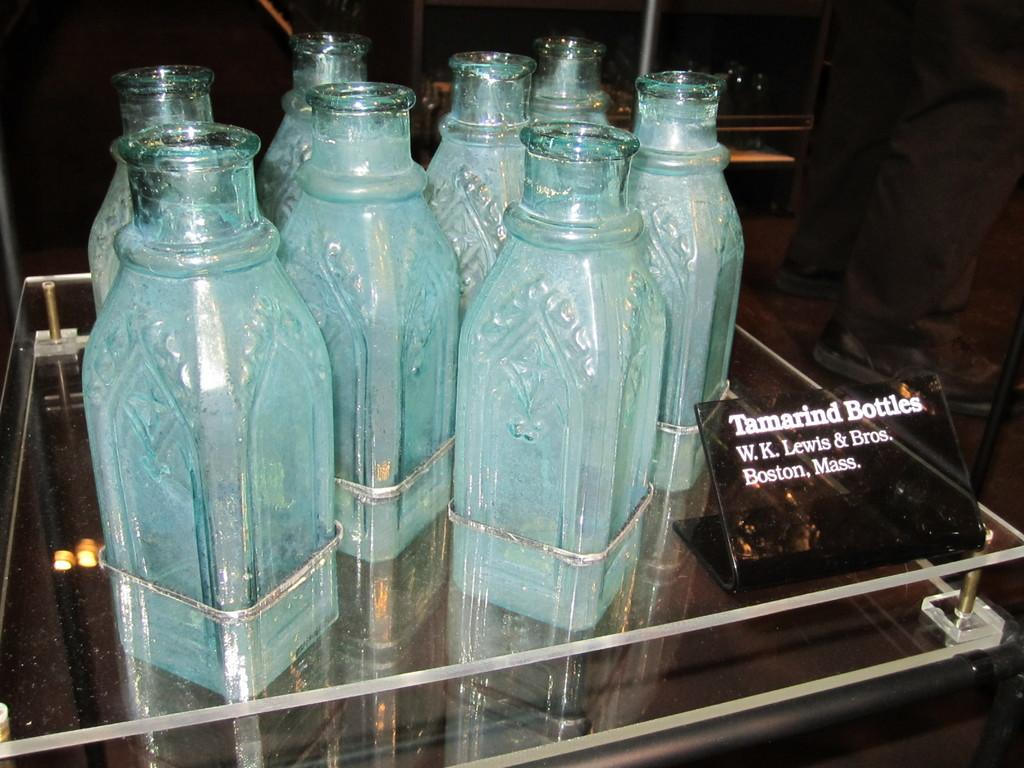Provide a one-sentence caption for the provided image. Vintage Tamarind Bottles W.K. Lewis & Bros. Boston, Mass. 